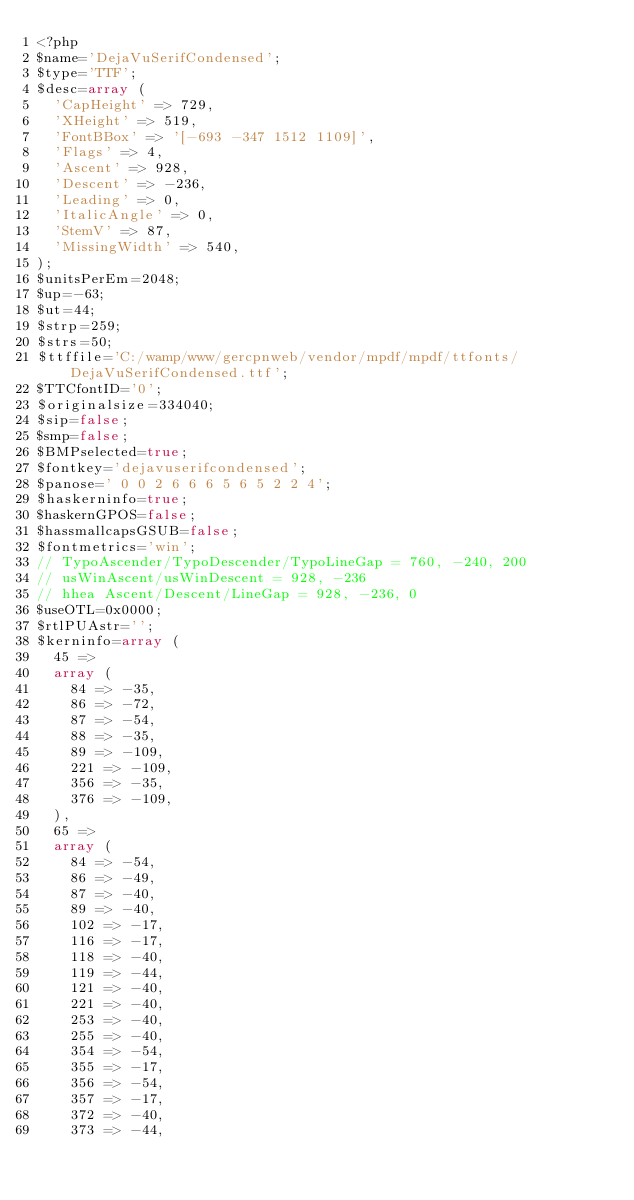Convert code to text. <code><loc_0><loc_0><loc_500><loc_500><_PHP_><?php
$name='DejaVuSerifCondensed';
$type='TTF';
$desc=array (
  'CapHeight' => 729,
  'XHeight' => 519,
  'FontBBox' => '[-693 -347 1512 1109]',
  'Flags' => 4,
  'Ascent' => 928,
  'Descent' => -236,
  'Leading' => 0,
  'ItalicAngle' => 0,
  'StemV' => 87,
  'MissingWidth' => 540,
);
$unitsPerEm=2048;
$up=-63;
$ut=44;
$strp=259;
$strs=50;
$ttffile='C:/wamp/www/gercpnweb/vendor/mpdf/mpdf/ttfonts/DejaVuSerifCondensed.ttf';
$TTCfontID='0';
$originalsize=334040;
$sip=false;
$smp=false;
$BMPselected=true;
$fontkey='dejavuserifcondensed';
$panose=' 0 0 2 6 6 6 5 6 5 2 2 4';
$haskerninfo=true;
$haskernGPOS=false;
$hassmallcapsGSUB=false;
$fontmetrics='win';
// TypoAscender/TypoDescender/TypoLineGap = 760, -240, 200
// usWinAscent/usWinDescent = 928, -236
// hhea Ascent/Descent/LineGap = 928, -236, 0
$useOTL=0x0000;
$rtlPUAstr='';
$kerninfo=array (
  45 => 
  array (
    84 => -35,
    86 => -72,
    87 => -54,
    88 => -35,
    89 => -109,
    221 => -109,
    356 => -35,
    376 => -109,
  ),
  65 => 
  array (
    84 => -54,
    86 => -49,
    87 => -40,
    89 => -40,
    102 => -17,
    116 => -17,
    118 => -40,
    119 => -44,
    121 => -40,
    221 => -40,
    253 => -40,
    255 => -40,
    354 => -54,
    355 => -17,
    356 => -54,
    357 => -17,
    372 => -40,
    373 => -44,</code> 